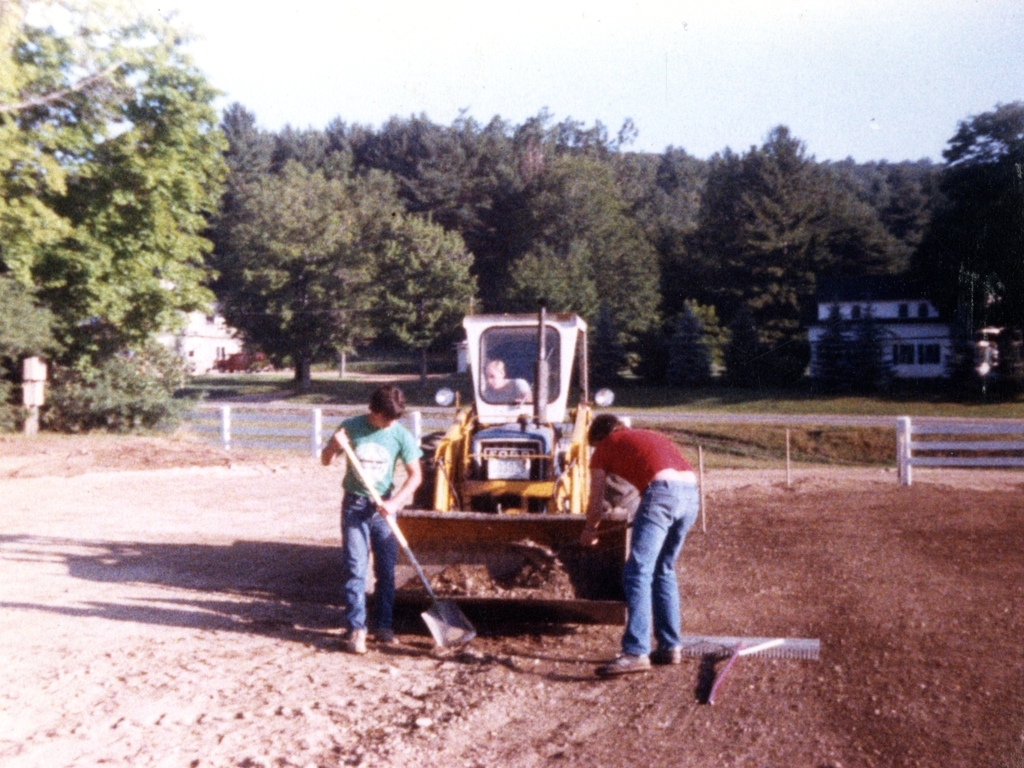Are there any quality issues with this image? The image exhibits a few quality issues, including noticeable graininess and signs of age such as color fading and minor damage. It also has lower resolution and sharpness, which reduce the level of detail visible. 